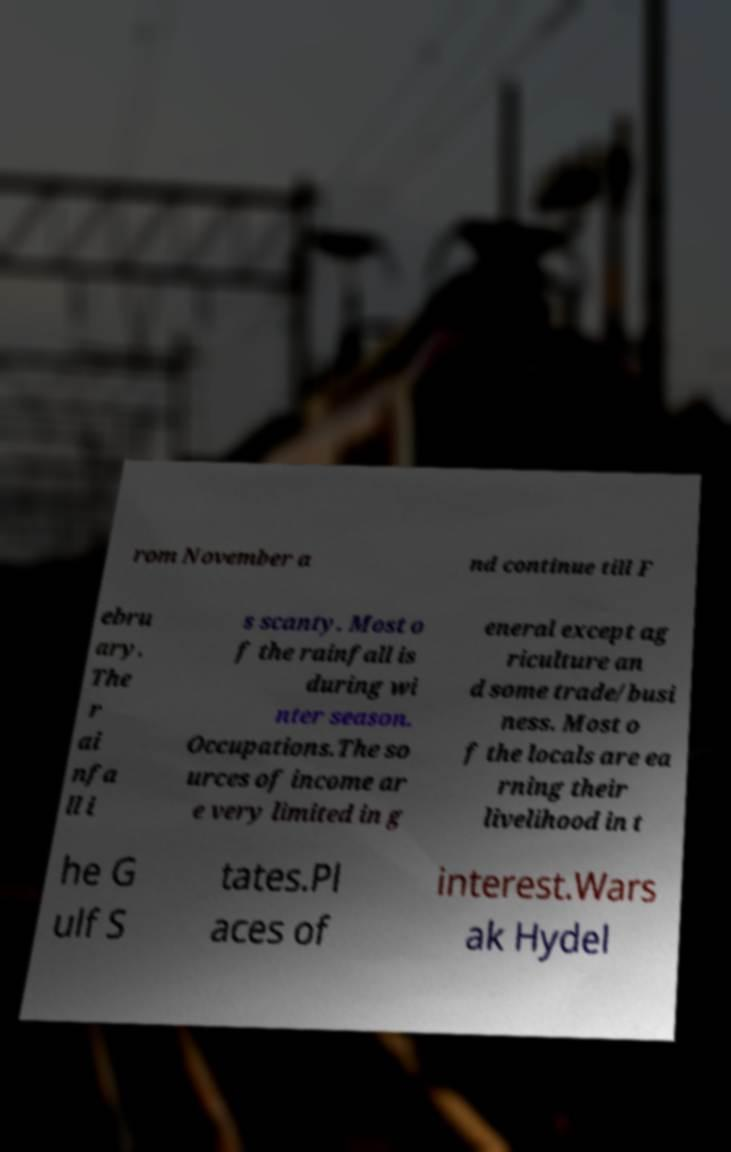I need the written content from this picture converted into text. Can you do that? rom November a nd continue till F ebru ary. The r ai nfa ll i s scanty. Most o f the rainfall is during wi nter season. Occupations.The so urces of income ar e very limited in g eneral except ag riculture an d some trade/busi ness. Most o f the locals are ea rning their livelihood in t he G ulf S tates.Pl aces of interest.Wars ak Hydel 